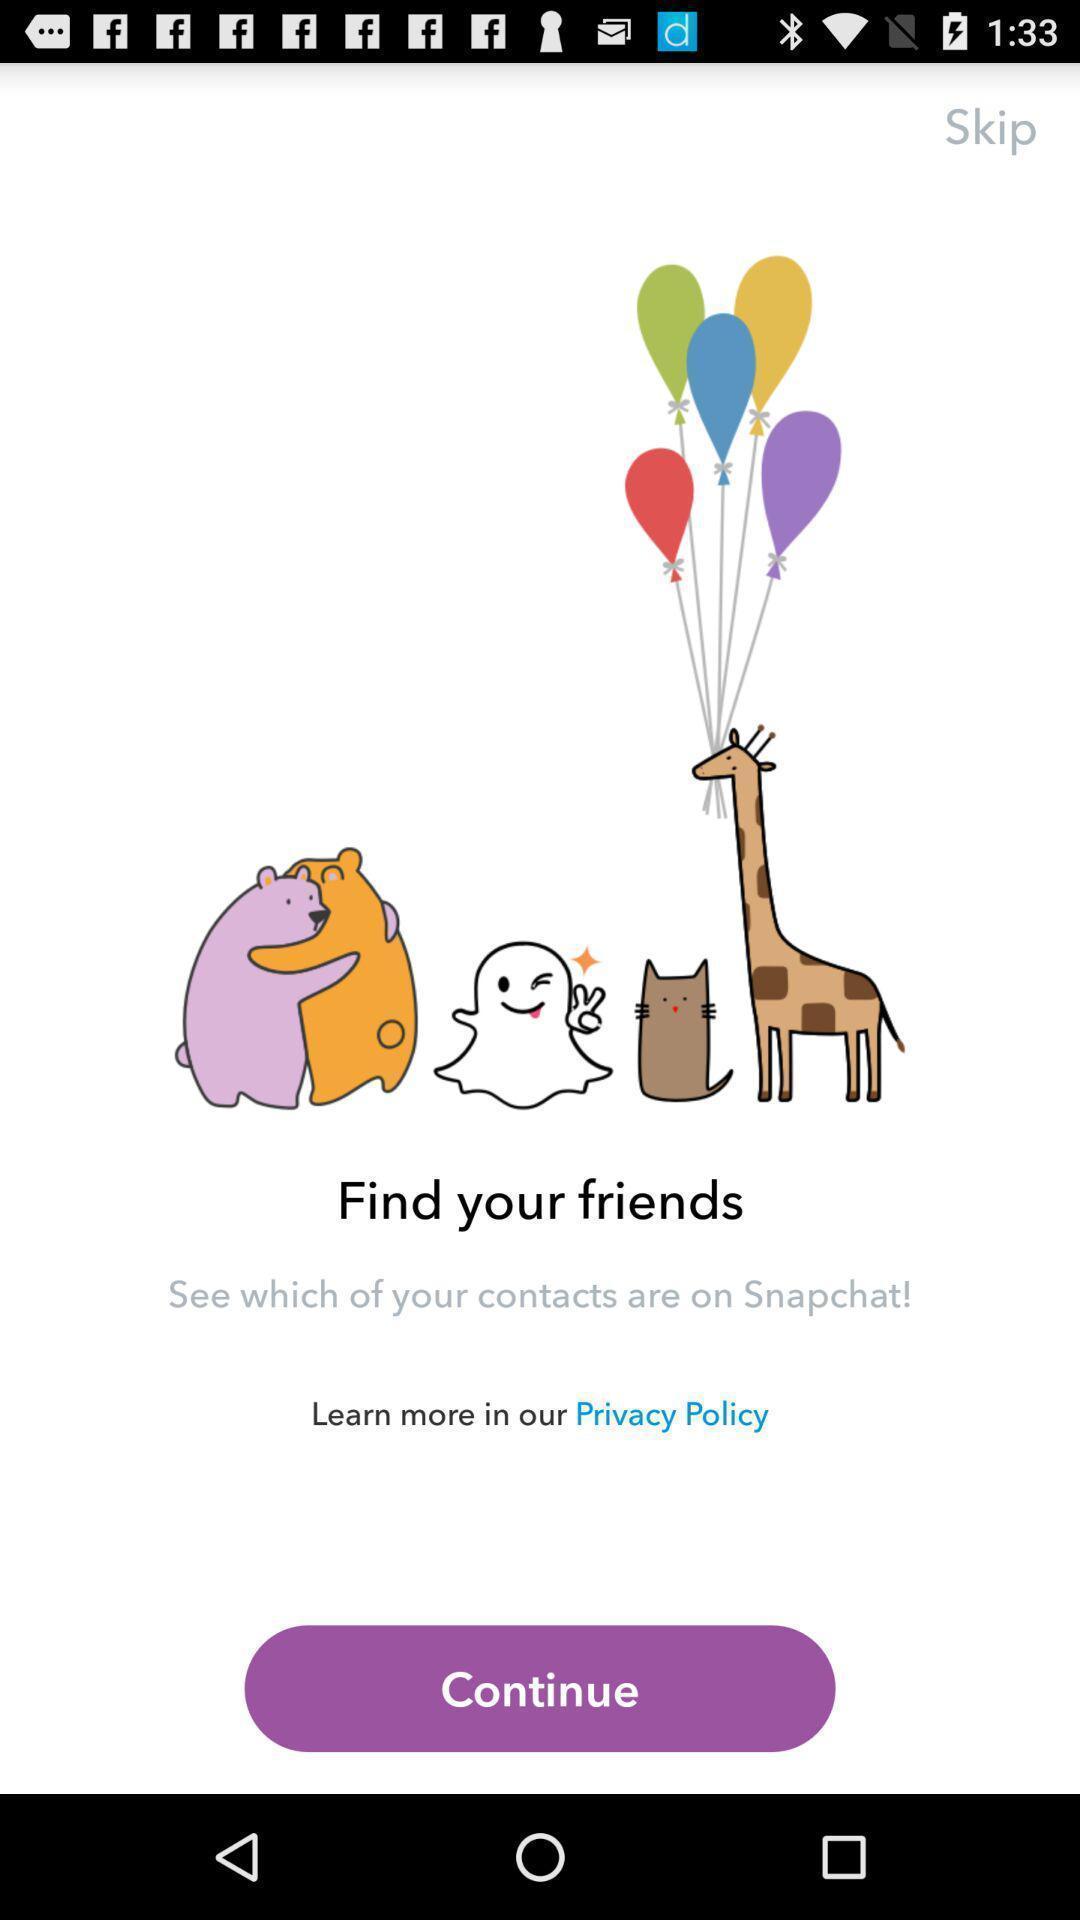Tell me about the visual elements in this screen capture. Welcome page of a social application. 